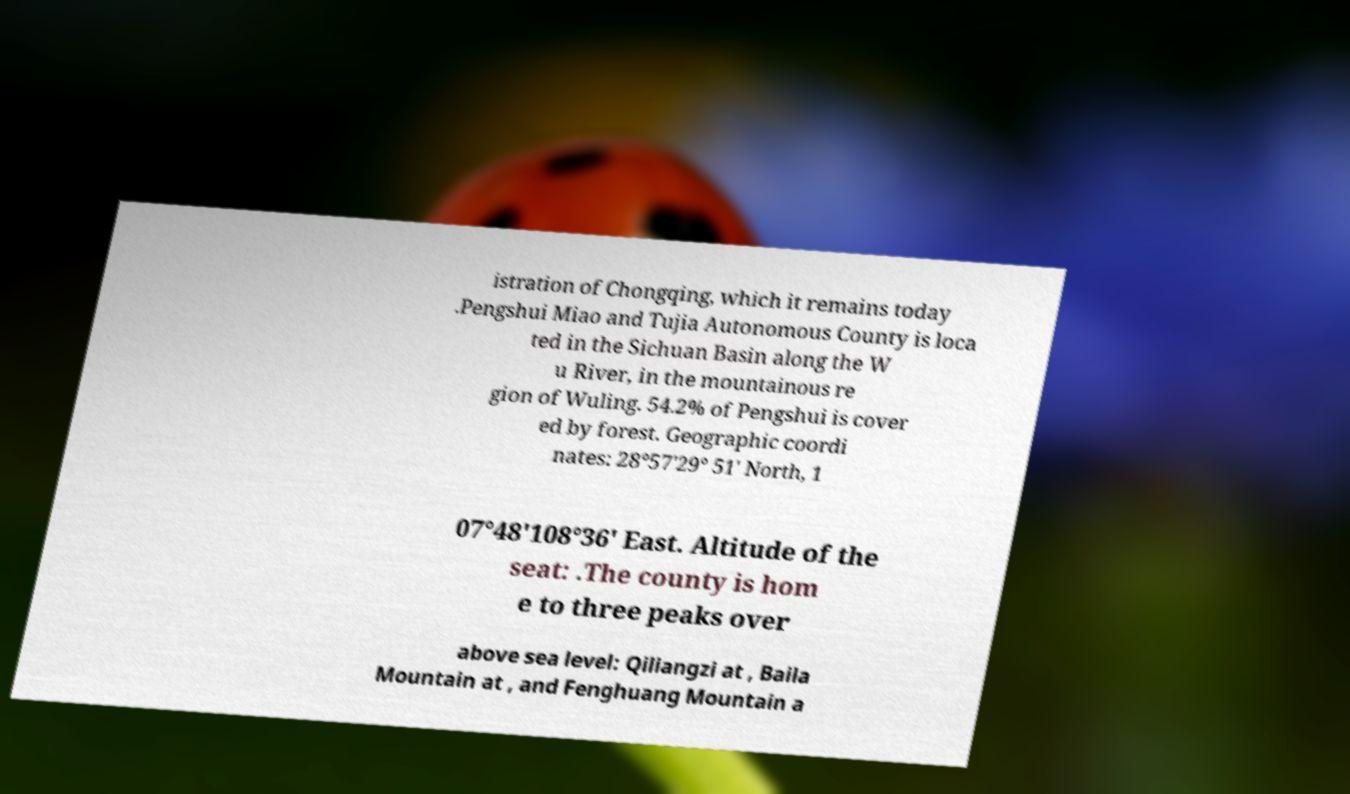What messages or text are displayed in this image? I need them in a readable, typed format. istration of Chongqing, which it remains today .Pengshui Miao and Tujia Autonomous County is loca ted in the Sichuan Basin along the W u River, in the mountainous re gion of Wuling. 54.2% of Pengshui is cover ed by forest. Geographic coordi nates: 28°57′29° 51′ North, 1 07°48′108°36′ East. Altitude of the seat: .The county is hom e to three peaks over above sea level: Qiliangzi at , Baila Mountain at , and Fenghuang Mountain a 